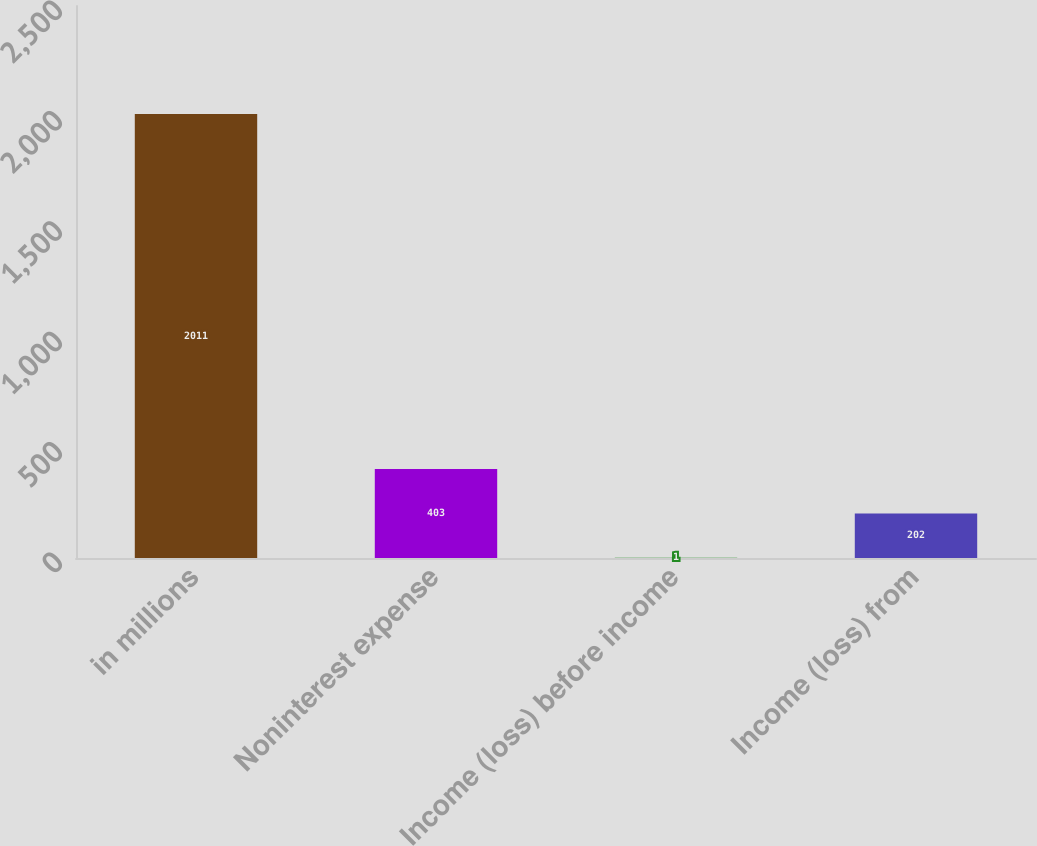<chart> <loc_0><loc_0><loc_500><loc_500><bar_chart><fcel>in millions<fcel>Noninterest expense<fcel>Income (loss) before income<fcel>Income (loss) from<nl><fcel>2011<fcel>403<fcel>1<fcel>202<nl></chart> 